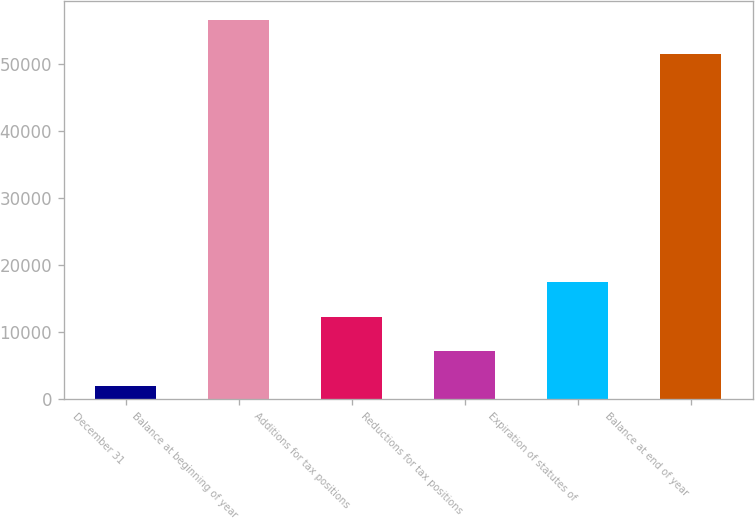Convert chart. <chart><loc_0><loc_0><loc_500><loc_500><bar_chart><fcel>December 31<fcel>Balance at beginning of year<fcel>Additions for tax positions<fcel>Reductions for tax positions<fcel>Expiration of statutes of<fcel>Balance at end of year<nl><fcel>2012<fcel>56674.1<fcel>12320.2<fcel>7166.1<fcel>17474.3<fcel>51520<nl></chart> 